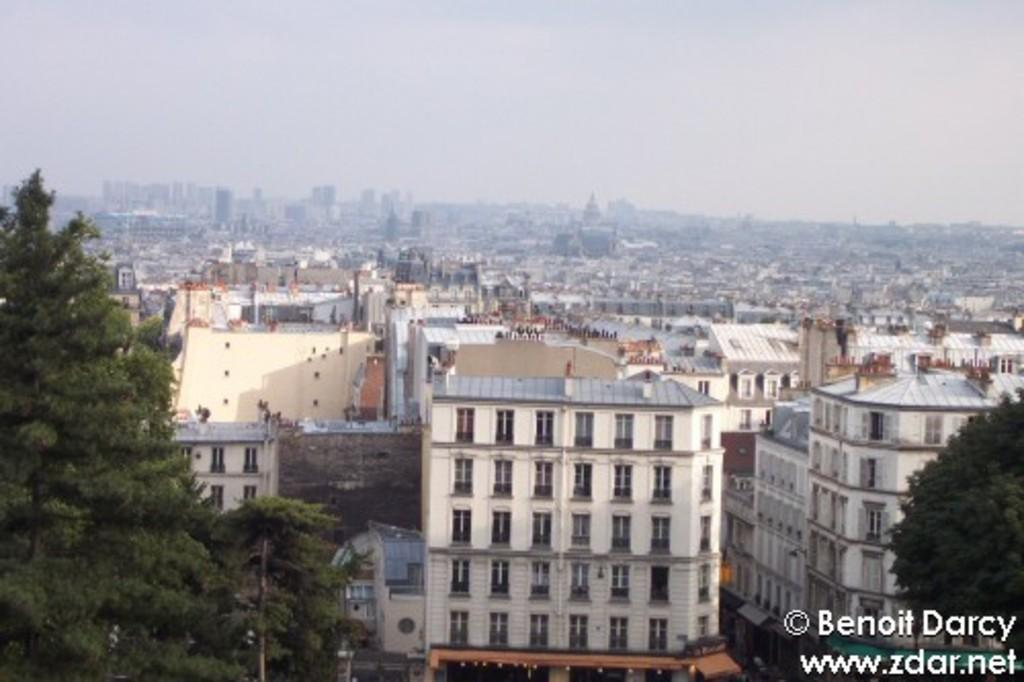What type of structures are visible in the image? There are many buildings and skyscrapers in the image. What can be seen on the left side of the image? There are trees on the left side of the image. What is present in the bottom right corner of the image? There is a watermark in the bottom right corner of the image. What is visible at the top of the image? The sky is visible at the top of the image. What can be observed in the sky? Clouds are present in the sky. How many passengers are visible in the image? There are no passengers present in the image. What type of notebook is being used by the person in the image? There is no person or notebook present in the image. 